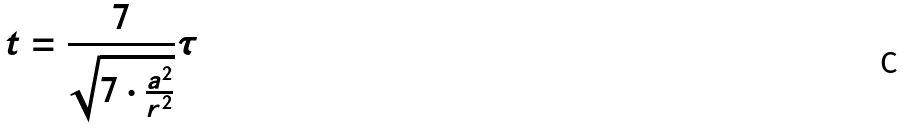<formula> <loc_0><loc_0><loc_500><loc_500>t = \frac { 7 } { \sqrt { 7 \cdot \frac { a ^ { 2 } } { r ^ { 2 } } } } \tau</formula> 